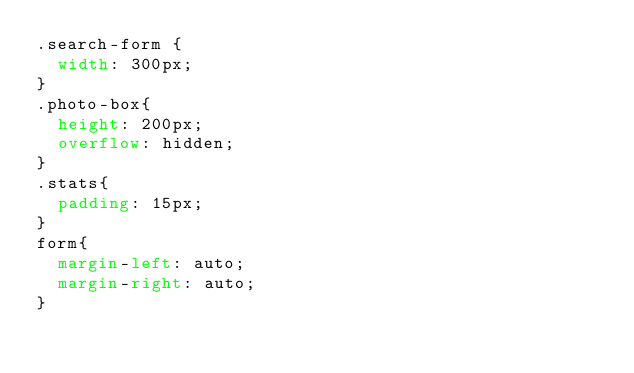Convert code to text. <code><loc_0><loc_0><loc_500><loc_500><_CSS_>.search-form {
  width: 300px;
}
.photo-box{
  height: 200px;
  overflow: hidden;
}
.stats{
  padding: 15px;
} 
form{
  margin-left: auto;
  margin-right: auto;
}</code> 